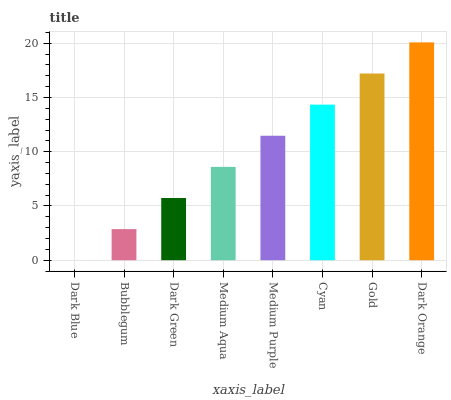Is Dark Blue the minimum?
Answer yes or no. Yes. Is Dark Orange the maximum?
Answer yes or no. Yes. Is Bubblegum the minimum?
Answer yes or no. No. Is Bubblegum the maximum?
Answer yes or no. No. Is Bubblegum greater than Dark Blue?
Answer yes or no. Yes. Is Dark Blue less than Bubblegum?
Answer yes or no. Yes. Is Dark Blue greater than Bubblegum?
Answer yes or no. No. Is Bubblegum less than Dark Blue?
Answer yes or no. No. Is Medium Purple the high median?
Answer yes or no. Yes. Is Medium Aqua the low median?
Answer yes or no. Yes. Is Dark Blue the high median?
Answer yes or no. No. Is Dark Orange the low median?
Answer yes or no. No. 